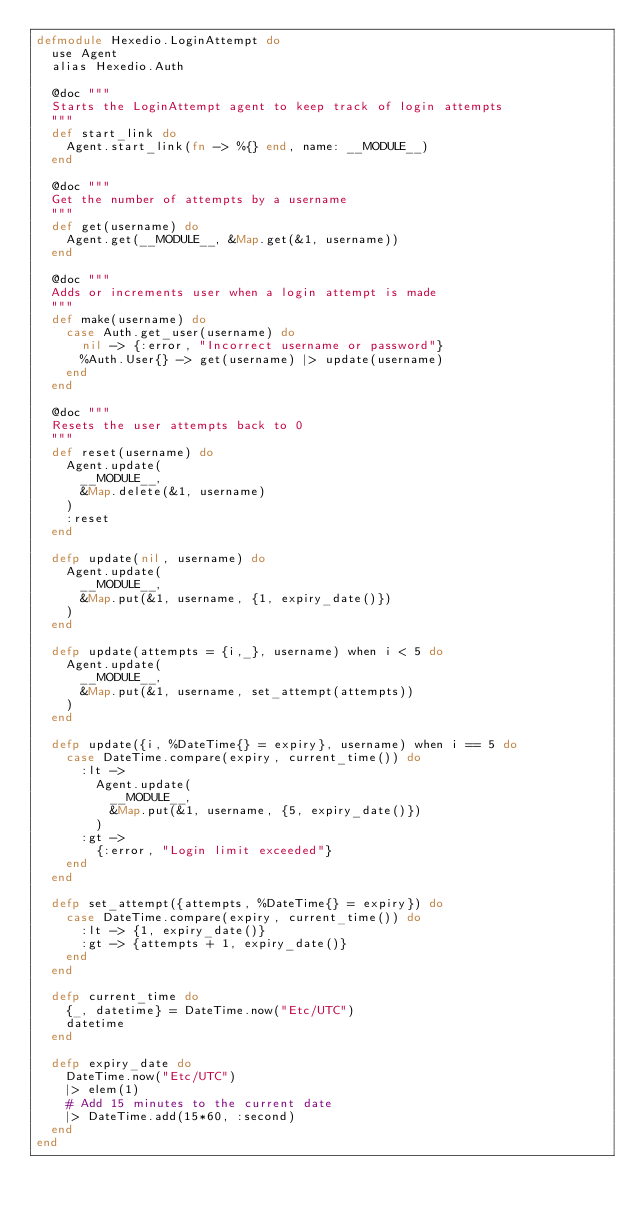<code> <loc_0><loc_0><loc_500><loc_500><_Elixir_>defmodule Hexedio.LoginAttempt do
  use Agent
  alias Hexedio.Auth

  @doc """
  Starts the LoginAttempt agent to keep track of login attempts
  """
  def start_link do
    Agent.start_link(fn -> %{} end, name: __MODULE__)
  end

  @doc """
  Get the number of attempts by a username
  """
  def get(username) do
    Agent.get(__MODULE__, &Map.get(&1, username))
  end

  @doc """
  Adds or increments user when a login attempt is made
  """
  def make(username) do
    case Auth.get_user(username) do
      nil -> {:error, "Incorrect username or password"}
      %Auth.User{} -> get(username) |> update(username)
    end
  end

  @doc """
  Resets the user attempts back to 0
  """
  def reset(username) do
    Agent.update(
      __MODULE__, 
      &Map.delete(&1, username)
    )
    :reset
  end

  defp update(nil, username) do 
    Agent.update(
      __MODULE__, 
      &Map.put(&1, username, {1, expiry_date()})
    )
  end

  defp update(attempts = {i,_}, username) when i < 5 do 
    Agent.update(
      __MODULE__, 
      &Map.put(&1, username, set_attempt(attempts))
    )
  end

  defp update({i, %DateTime{} = expiry}, username) when i == 5 do 
    case DateTime.compare(expiry, current_time()) do
      :lt ->
        Agent.update(
          __MODULE__, 
          &Map.put(&1, username, {5, expiry_date()})
        )
      :gt -> 
        {:error, "Login limit exceeded"}
    end
  end

  defp set_attempt({attempts, %DateTime{} = expiry}) do
    case DateTime.compare(expiry, current_time()) do
      :lt -> {1, expiry_date()}
      :gt -> {attempts + 1, expiry_date()}
    end
  end

  defp current_time do
    {_, datetime} = DateTime.now("Etc/UTC")
    datetime
  end

  defp expiry_date do
    DateTime.now("Etc/UTC")
    |> elem(1)
    # Add 15 minutes to the current date
    |> DateTime.add(15*60, :second)
  end
end
</code> 